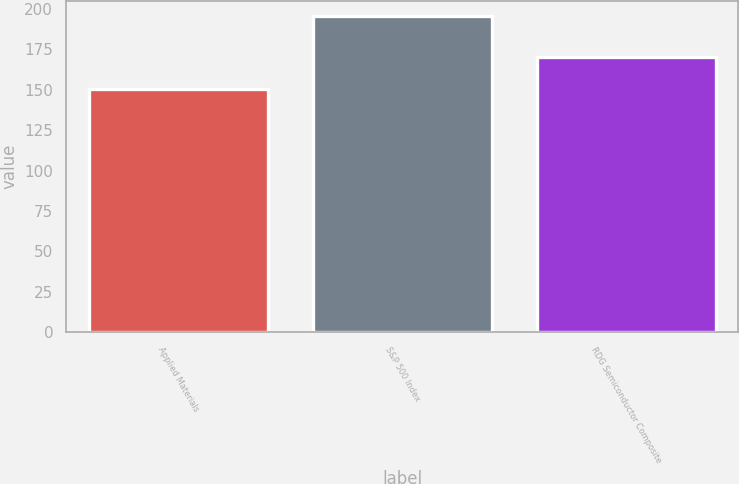Convert chart to OTSL. <chart><loc_0><loc_0><loc_500><loc_500><bar_chart><fcel>Applied Materials<fcel>S&P 500 Index<fcel>RDG Semiconductor Composite<nl><fcel>150.26<fcel>195.37<fcel>170.4<nl></chart> 